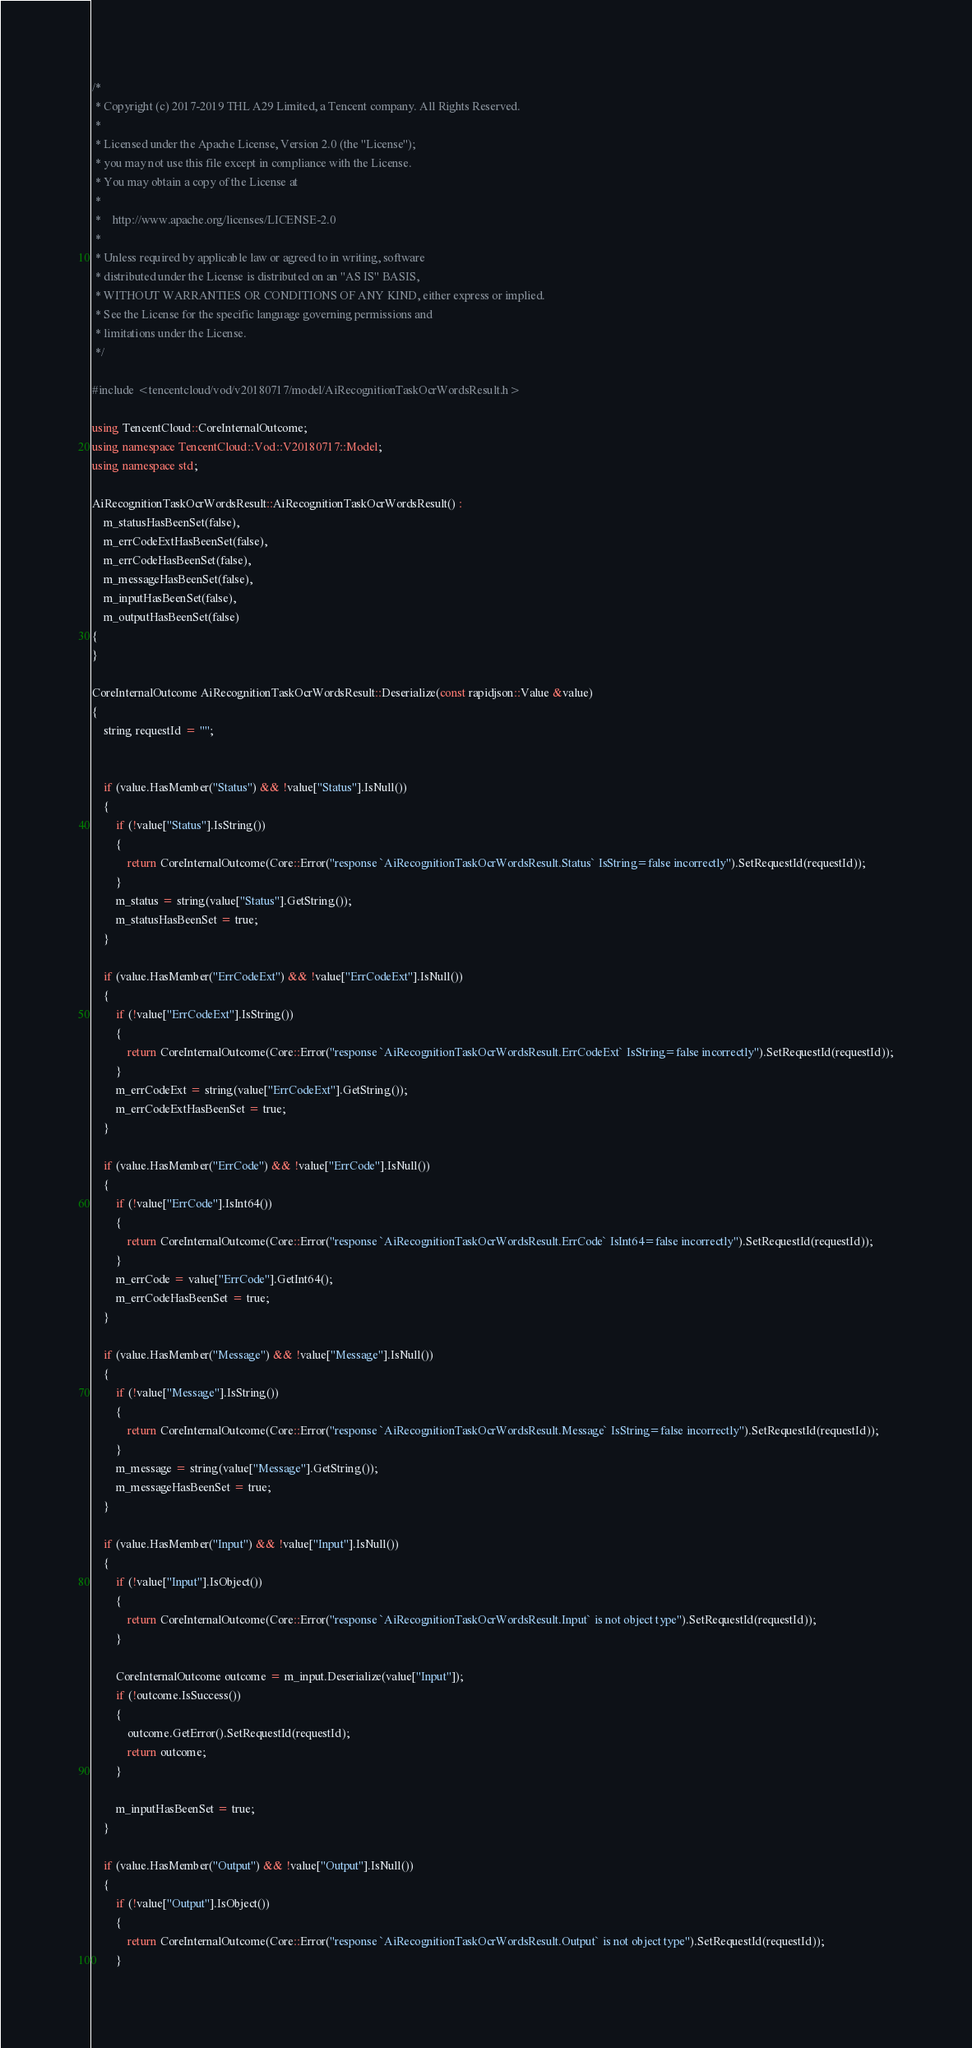Convert code to text. <code><loc_0><loc_0><loc_500><loc_500><_C++_>/*
 * Copyright (c) 2017-2019 THL A29 Limited, a Tencent company. All Rights Reserved.
 *
 * Licensed under the Apache License, Version 2.0 (the "License");
 * you may not use this file except in compliance with the License.
 * You may obtain a copy of the License at
 *
 *    http://www.apache.org/licenses/LICENSE-2.0
 *
 * Unless required by applicable law or agreed to in writing, software
 * distributed under the License is distributed on an "AS IS" BASIS,
 * WITHOUT WARRANTIES OR CONDITIONS OF ANY KIND, either express or implied.
 * See the License for the specific language governing permissions and
 * limitations under the License.
 */

#include <tencentcloud/vod/v20180717/model/AiRecognitionTaskOcrWordsResult.h>

using TencentCloud::CoreInternalOutcome;
using namespace TencentCloud::Vod::V20180717::Model;
using namespace std;

AiRecognitionTaskOcrWordsResult::AiRecognitionTaskOcrWordsResult() :
    m_statusHasBeenSet(false),
    m_errCodeExtHasBeenSet(false),
    m_errCodeHasBeenSet(false),
    m_messageHasBeenSet(false),
    m_inputHasBeenSet(false),
    m_outputHasBeenSet(false)
{
}

CoreInternalOutcome AiRecognitionTaskOcrWordsResult::Deserialize(const rapidjson::Value &value)
{
    string requestId = "";


    if (value.HasMember("Status") && !value["Status"].IsNull())
    {
        if (!value["Status"].IsString())
        {
            return CoreInternalOutcome(Core::Error("response `AiRecognitionTaskOcrWordsResult.Status` IsString=false incorrectly").SetRequestId(requestId));
        }
        m_status = string(value["Status"].GetString());
        m_statusHasBeenSet = true;
    }

    if (value.HasMember("ErrCodeExt") && !value["ErrCodeExt"].IsNull())
    {
        if (!value["ErrCodeExt"].IsString())
        {
            return CoreInternalOutcome(Core::Error("response `AiRecognitionTaskOcrWordsResult.ErrCodeExt` IsString=false incorrectly").SetRequestId(requestId));
        }
        m_errCodeExt = string(value["ErrCodeExt"].GetString());
        m_errCodeExtHasBeenSet = true;
    }

    if (value.HasMember("ErrCode") && !value["ErrCode"].IsNull())
    {
        if (!value["ErrCode"].IsInt64())
        {
            return CoreInternalOutcome(Core::Error("response `AiRecognitionTaskOcrWordsResult.ErrCode` IsInt64=false incorrectly").SetRequestId(requestId));
        }
        m_errCode = value["ErrCode"].GetInt64();
        m_errCodeHasBeenSet = true;
    }

    if (value.HasMember("Message") && !value["Message"].IsNull())
    {
        if (!value["Message"].IsString())
        {
            return CoreInternalOutcome(Core::Error("response `AiRecognitionTaskOcrWordsResult.Message` IsString=false incorrectly").SetRequestId(requestId));
        }
        m_message = string(value["Message"].GetString());
        m_messageHasBeenSet = true;
    }

    if (value.HasMember("Input") && !value["Input"].IsNull())
    {
        if (!value["Input"].IsObject())
        {
            return CoreInternalOutcome(Core::Error("response `AiRecognitionTaskOcrWordsResult.Input` is not object type").SetRequestId(requestId));
        }

        CoreInternalOutcome outcome = m_input.Deserialize(value["Input"]);
        if (!outcome.IsSuccess())
        {
            outcome.GetError().SetRequestId(requestId);
            return outcome;
        }

        m_inputHasBeenSet = true;
    }

    if (value.HasMember("Output") && !value["Output"].IsNull())
    {
        if (!value["Output"].IsObject())
        {
            return CoreInternalOutcome(Core::Error("response `AiRecognitionTaskOcrWordsResult.Output` is not object type").SetRequestId(requestId));
        }
</code> 